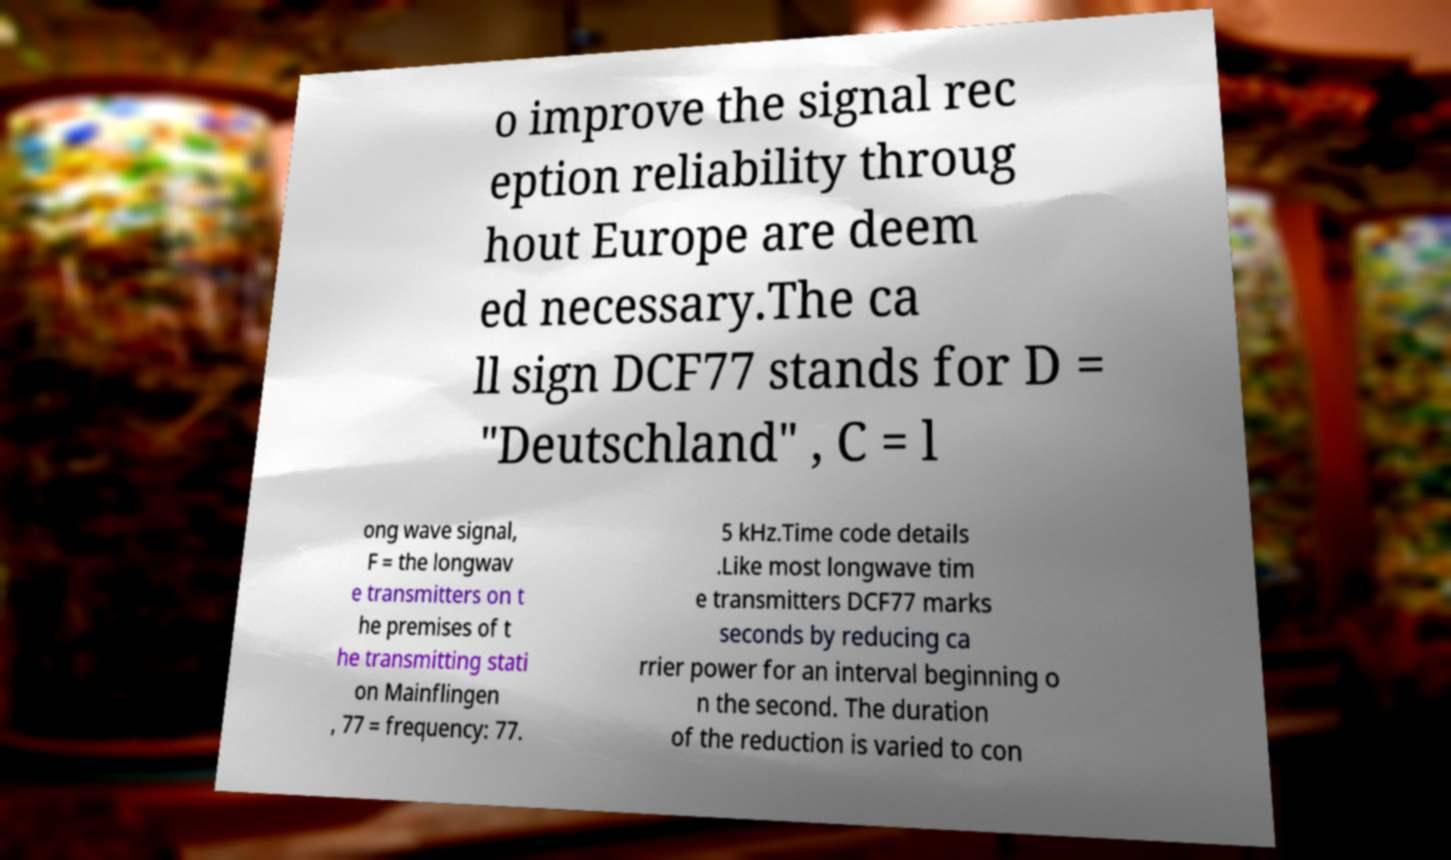Can you accurately transcribe the text from the provided image for me? o improve the signal rec eption reliability throug hout Europe are deem ed necessary.The ca ll sign DCF77 stands for D = "Deutschland" , C = l ong wave signal, F = the longwav e transmitters on t he premises of t he transmitting stati on Mainflingen , 77 = frequency: 77. 5 kHz.Time code details .Like most longwave tim e transmitters DCF77 marks seconds by reducing ca rrier power for an interval beginning o n the second. The duration of the reduction is varied to con 